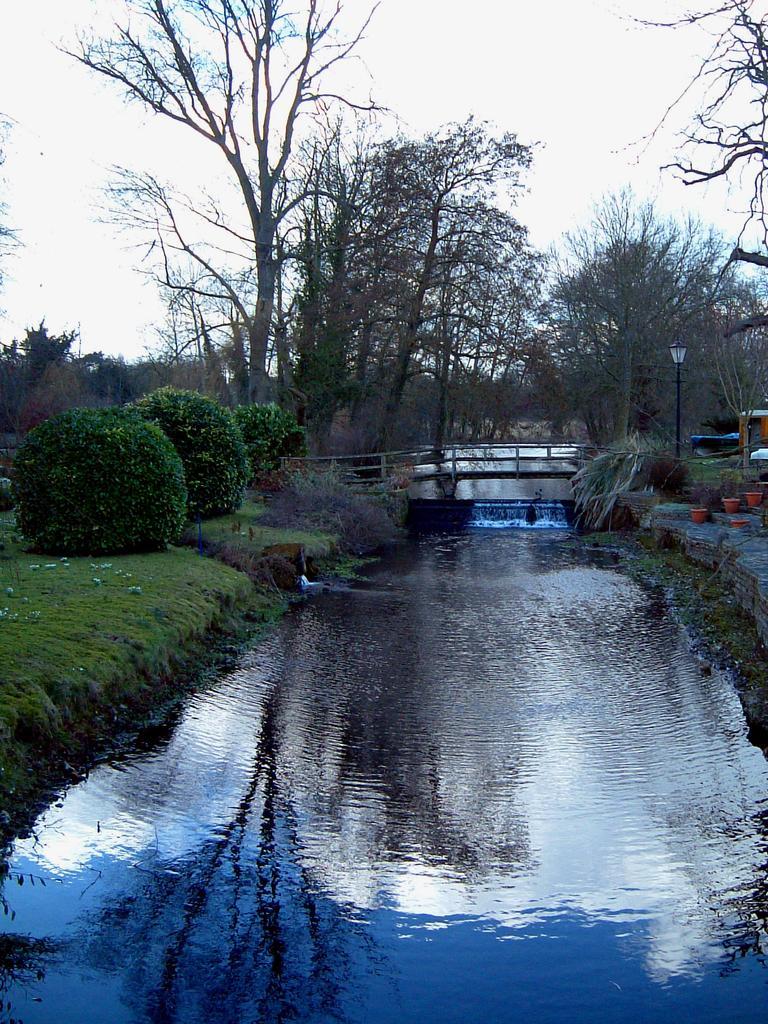Please provide a concise description of this image. In the center of the image, there is water and we can see a bridge. In the background, there are hedges, trees, lights, flower pots and stairs. At the top, there is sky. 